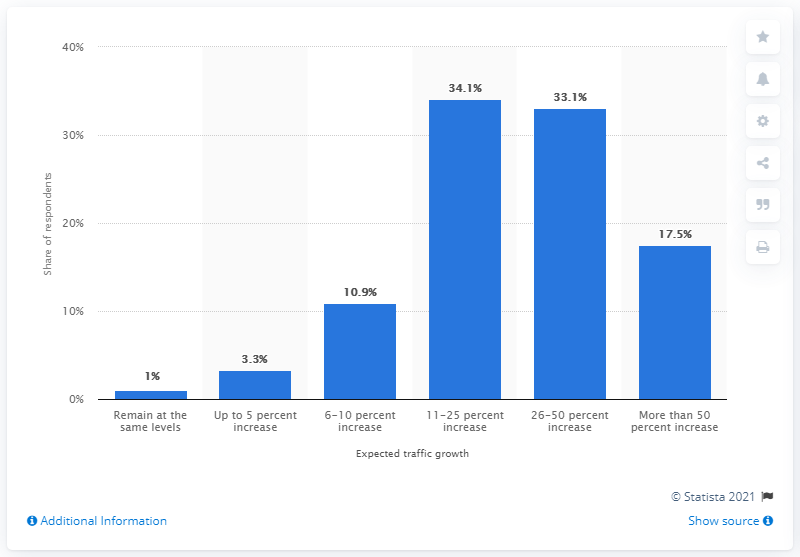Point out several critical features in this image. According to a survey conducted in 2014, 34.1% of retailers predicted that traffic to their stores on Christmas Day would increase by between 11-25% compared to a typical day. According to a survey, 34.1% of retailers expect online traffic to increase on Christmas Day. 